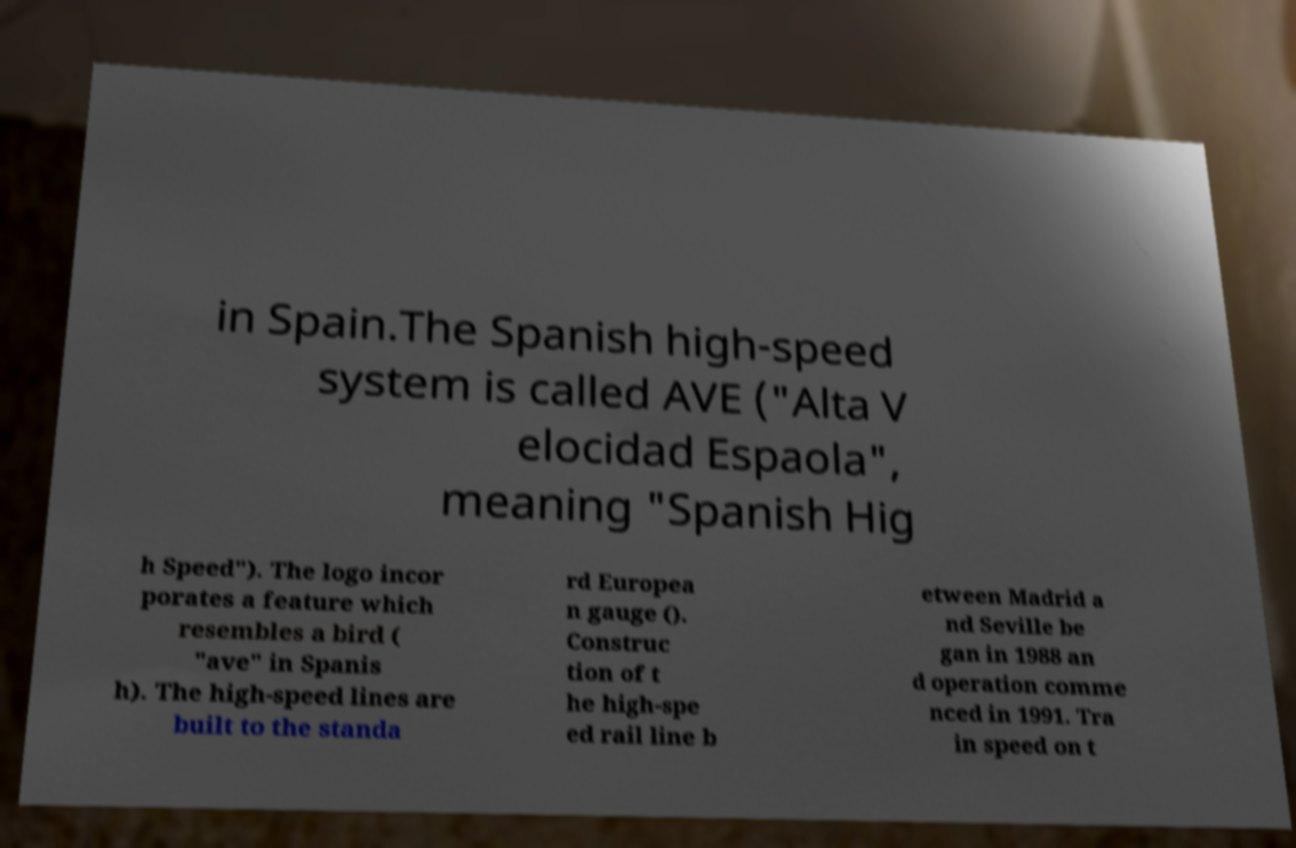Could you extract and type out the text from this image? in Spain.The Spanish high-speed system is called AVE ("Alta V elocidad Espaola", meaning "Spanish Hig h Speed"). The logo incor porates a feature which resembles a bird ( "ave" in Spanis h). The high-speed lines are built to the standa rd Europea n gauge (). Construc tion of t he high-spe ed rail line b etween Madrid a nd Seville be gan in 1988 an d operation comme nced in 1991. Tra in speed on t 